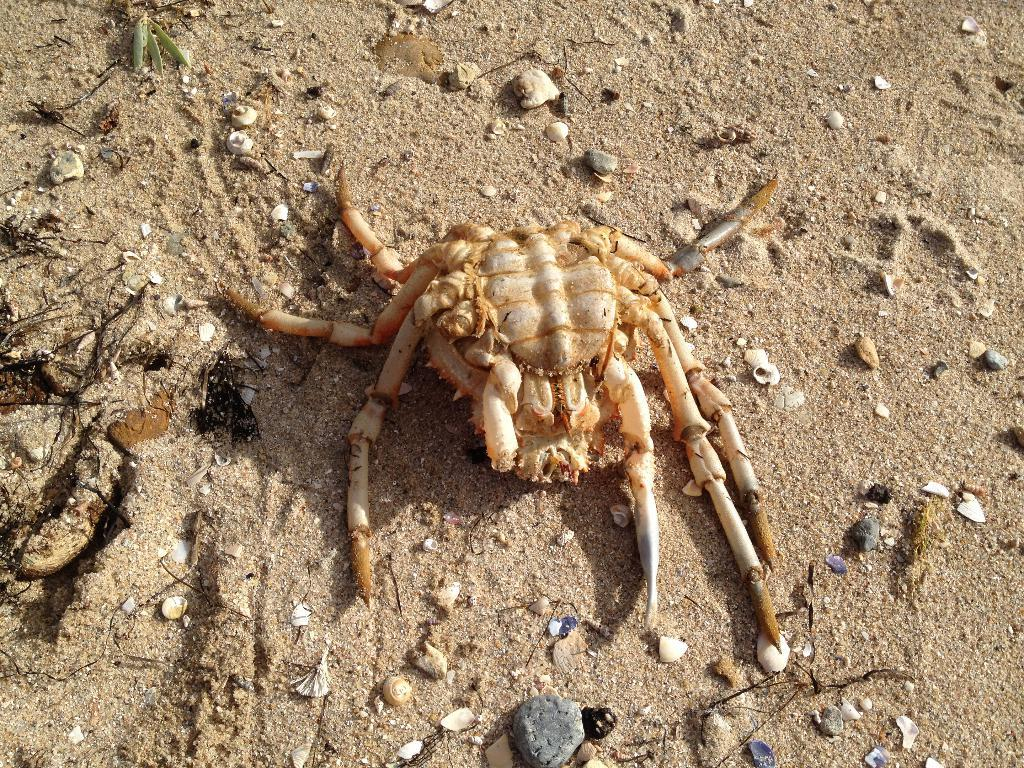What is the main subject of the image? The main subject of the image is a spider on the sand. What type of terrain is visible in the image? The terrain is sand, as mentioned in the fact. Are there any other objects or features visible in the image? Yes, there are stones visible in the image. Can you describe the objects on the ground? The objects on the ground are not specified, but we know there are stones present. How many eggs are being factored in the image? There are no eggs or factoring mentioned in the image. The image features a spider on the sand and stones visible on the ground. 